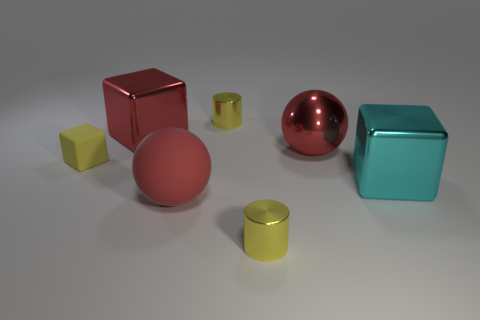Subtract all cyan cubes. How many cubes are left? 2 Add 3 metal cubes. How many objects exist? 10 Subtract all red blocks. How many blocks are left? 2 Subtract 2 cylinders. How many cylinders are left? 0 Add 7 red matte balls. How many red matte balls are left? 8 Add 7 large gray metal cubes. How many large gray metal cubes exist? 7 Subtract 0 gray balls. How many objects are left? 7 Subtract all balls. How many objects are left? 5 Subtract all brown cylinders. Subtract all brown blocks. How many cylinders are left? 2 Subtract all big red matte objects. Subtract all large red spheres. How many objects are left? 4 